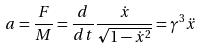Convert formula to latex. <formula><loc_0><loc_0><loc_500><loc_500>a = \frac { F } { M } = \frac { d } { d t } \frac { \dot { x } } { \sqrt { 1 - \dot { x } ^ { 2 } } } = \gamma ^ { 3 } \ddot { x }</formula> 